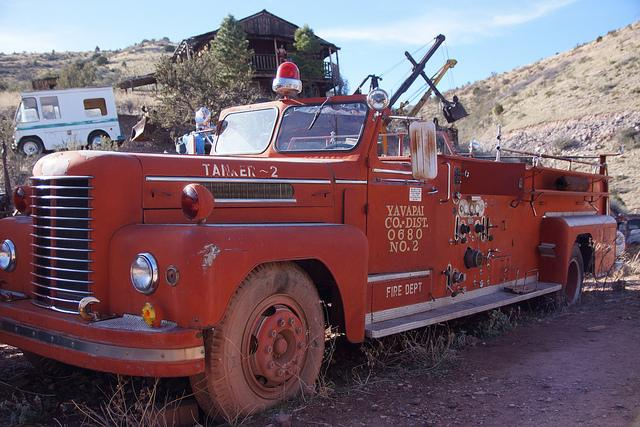What sort of emergency is the truck seen here prepared to immediately handle? Please explain your reasoning. none. Fire departments can deal with medical emergencies. 